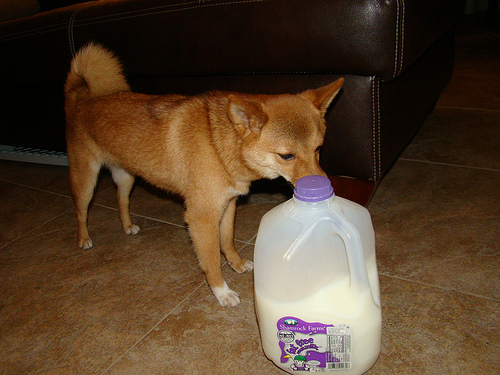<image>
Is there a dog in the milk? No. The dog is not contained within the milk. These objects have a different spatial relationship. 